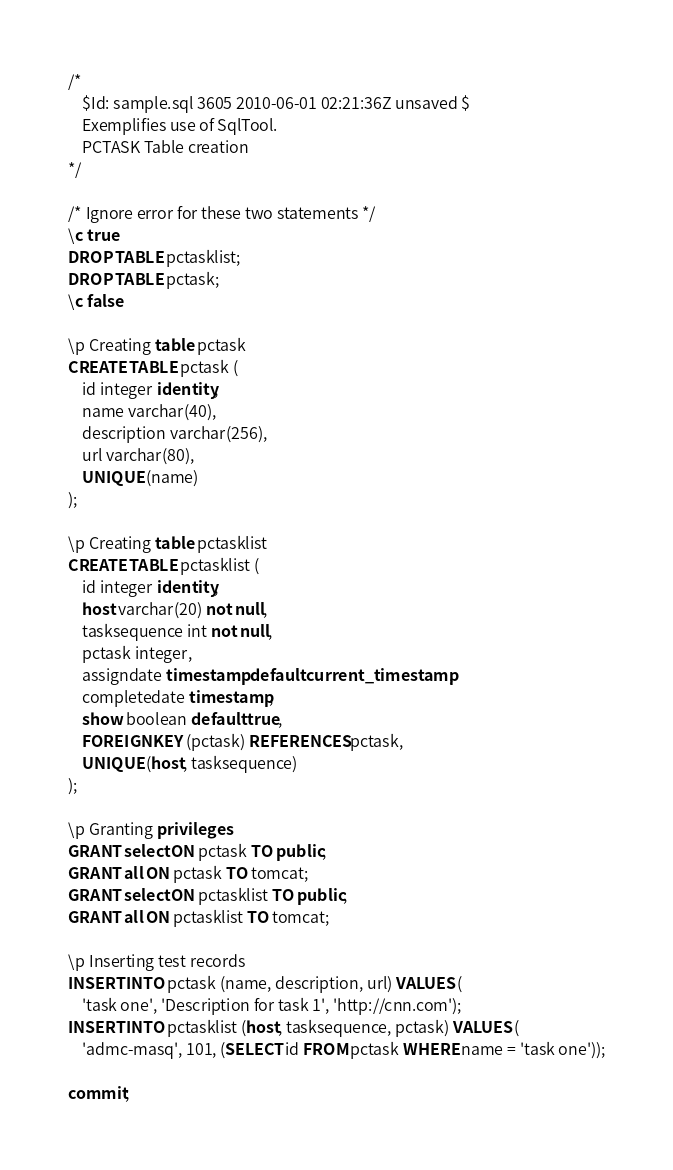Convert code to text. <code><loc_0><loc_0><loc_500><loc_500><_SQL_>/*
    $Id: sample.sql 3605 2010-06-01 02:21:36Z unsaved $
    Exemplifies use of SqlTool.
    PCTASK Table creation
*/

/* Ignore error for these two statements */
\c true
DROP TABLE pctasklist;
DROP TABLE pctask;
\c false

\p Creating table pctask
CREATE TABLE pctask (
    id integer identity,
    name varchar(40),
    description varchar(256),
    url varchar(80),
    UNIQUE (name)
);

\p Creating table pctasklist
CREATE TABLE pctasklist (
    id integer identity,
    host varchar(20) not null,
    tasksequence int not null,
    pctask integer,
    assigndate timestamp default current_timestamp,
    completedate timestamp,
    show boolean default true,
    FOREIGN KEY (pctask) REFERENCES pctask,
    UNIQUE (host, tasksequence)
);

\p Granting privileges
GRANT select ON pctask TO public;
GRANT all ON pctask TO tomcat;
GRANT select ON pctasklist TO public;
GRANT all ON pctasklist TO tomcat;

\p Inserting test records
INSERT INTO pctask (name, description, url) VALUES (
    'task one', 'Description for task 1', 'http://cnn.com');
INSERT INTO pctasklist (host, tasksequence, pctask) VALUES (
    'admc-masq', 101, (SELECT id FROM pctask WHERE name = 'task one'));

commit;
</code> 